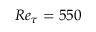<formula> <loc_0><loc_0><loc_500><loc_500>R e _ { \tau } = 5 5 0</formula> 